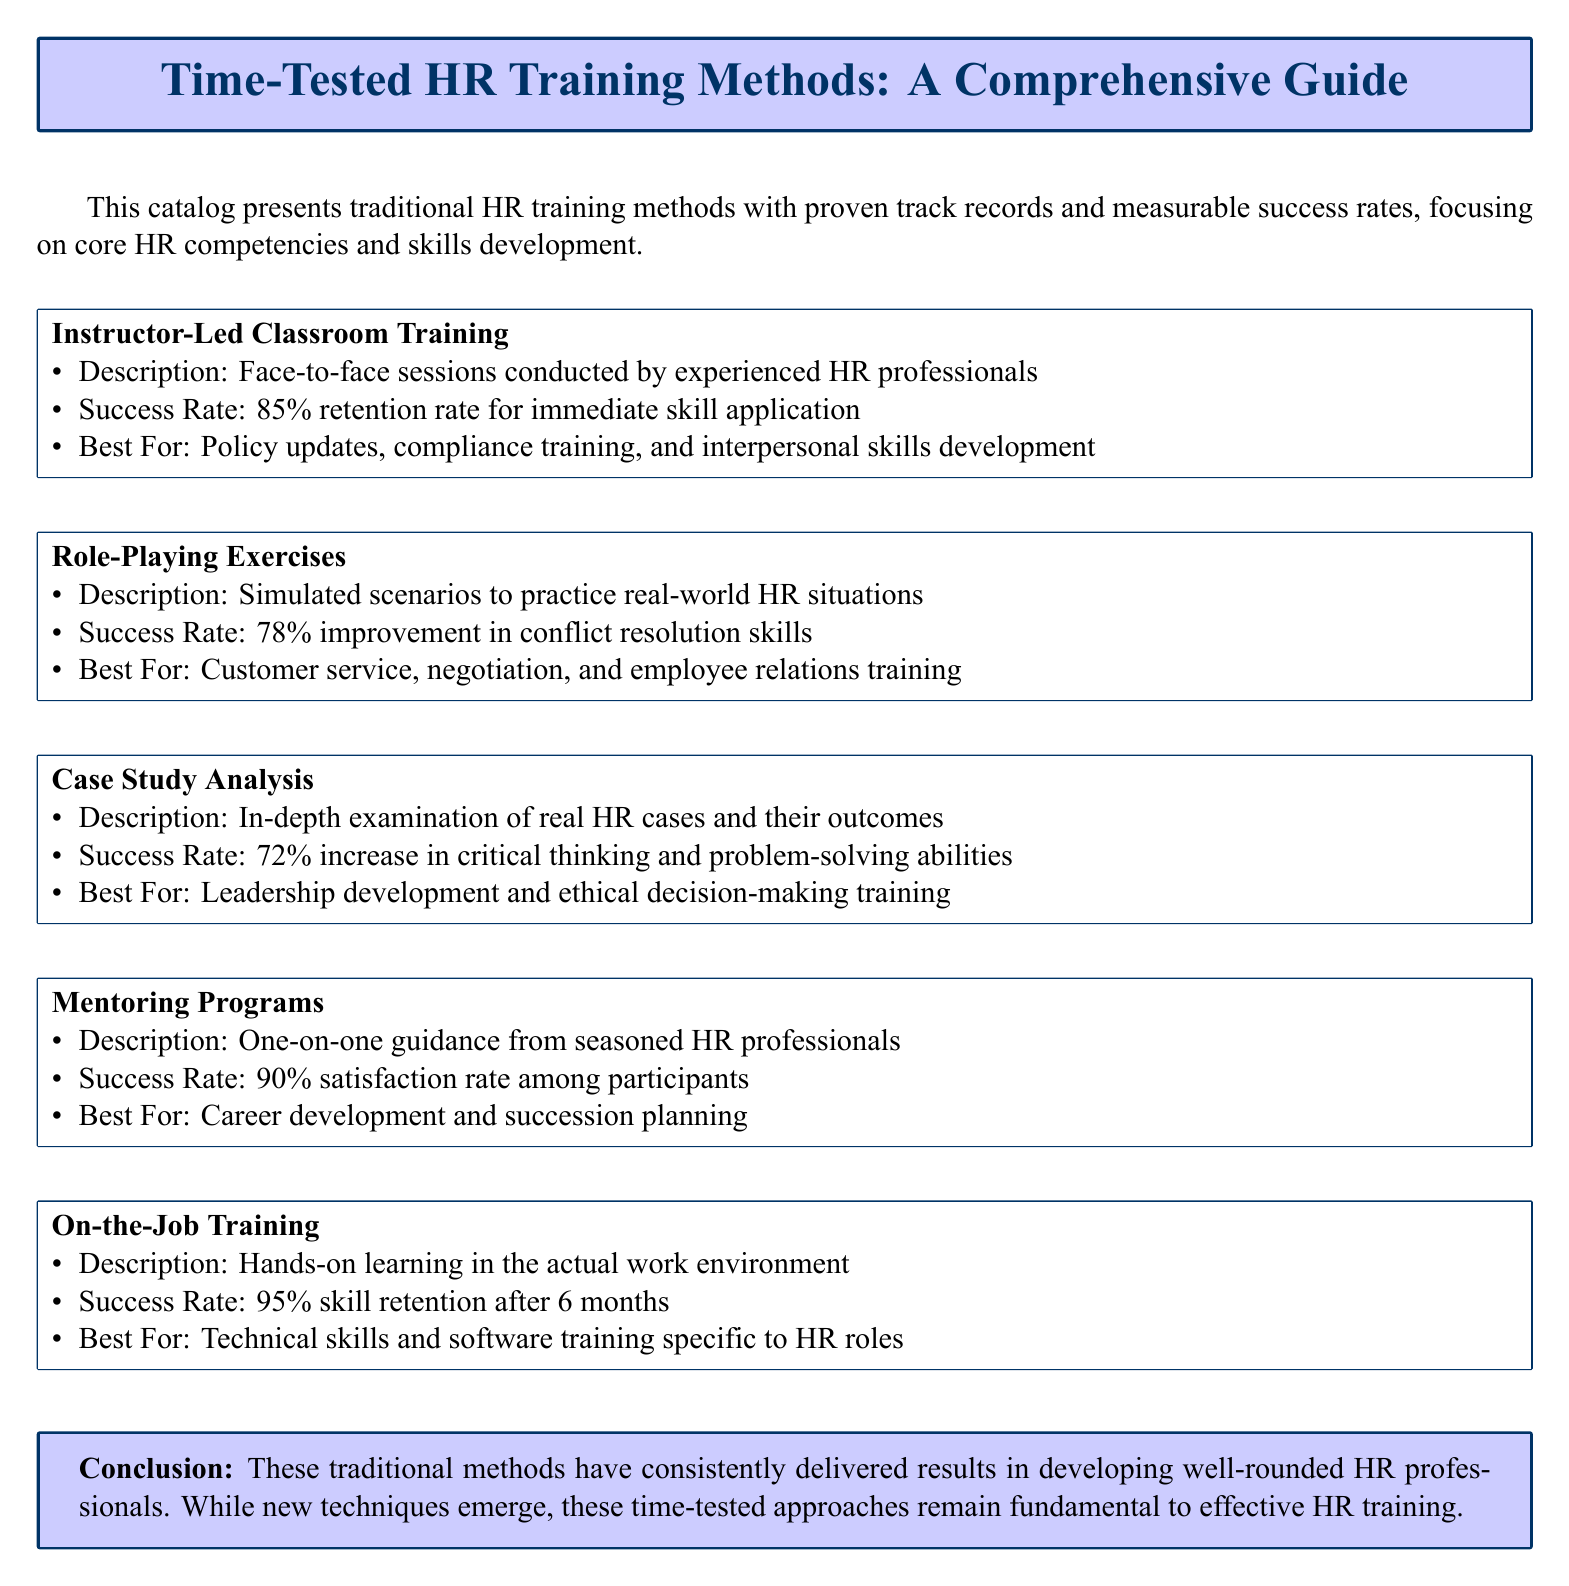What is the success rate for instructor-led classroom training? The success rate for instructor-led classroom training is noted in the document as an 85% retention rate for immediate skill application.
Answer: 85% What method has the highest success rate? The method with the highest success rate is on-the-job training, which has a 95% skill retention rate after 6 months.
Answer: 95% Which training method is best for policy updates? The method best for policy updates is instructor-led classroom training, as mentioned in the document.
Answer: Instructor-Led Classroom Training What improvement percentage is reported for conflict resolution skills? The document states that role-playing exercises result in a 78% improvement in conflict resolution skills.
Answer: 78% How many times is the word "training" mentioned in the document? The word "training" appears multiple times throughout the document, specifically in the context of HR training methods.
Answer: 6 Which training method has a 90% satisfaction rate? Mentoring programs have a 90% satisfaction rate among participants, as outlined in the document.
Answer: Mentoring Programs What is the best training method for technical skills? The best training method for technical skills is on-the-job training, as detailed in the document.
Answer: On-the-Job Training What is the main focus of the catalog? The main focus of the catalog is on traditional HR training methods with proven track records and measurable success rates.
Answer: Traditional HR training methods What is the success rate for case study analysis? The success rate noted for case study analysis in the document is a 72% increase in critical thinking and problem-solving abilities.
Answer: 72% 